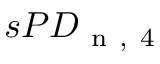Convert formula to latex. <formula><loc_0><loc_0><loc_500><loc_500>s P D _ { n , 4 }</formula> 